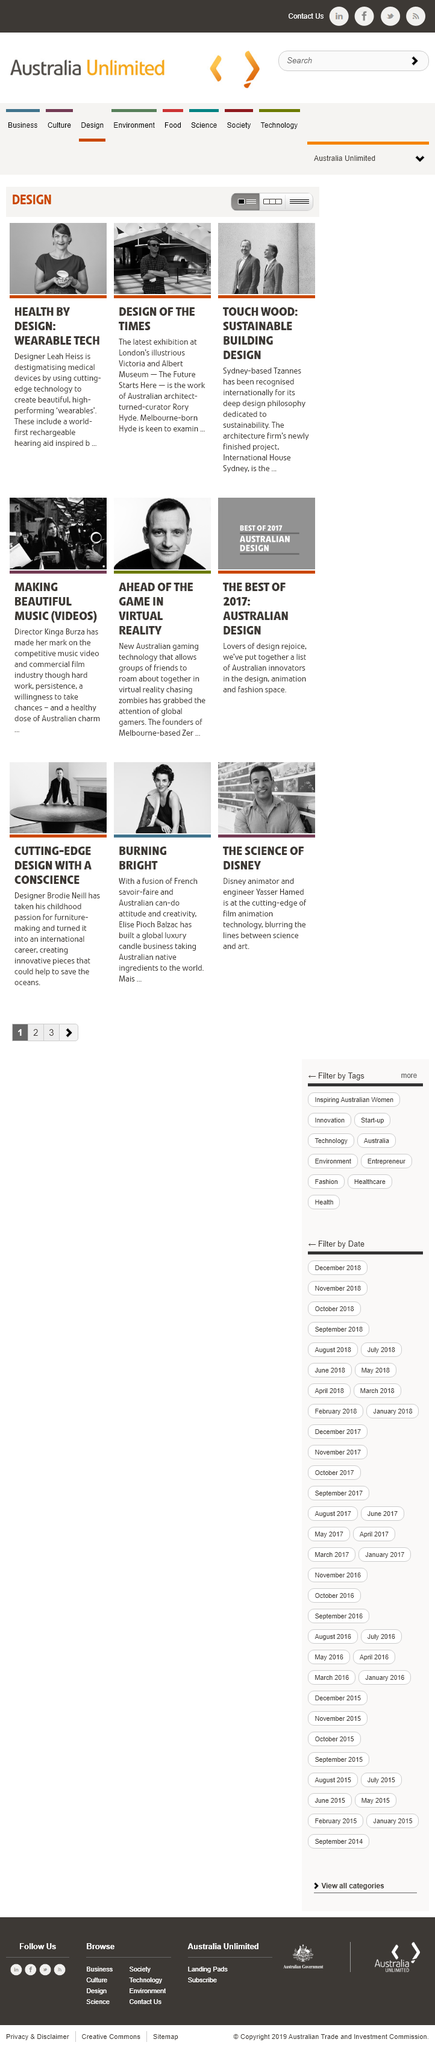Point out several critical features in this image. Tzannes is based in Sydney, and it is known for its innovative architectural designs. Rory Hyde, who was born in Melbourne, is known for his contributions to the field of architecture and design. Leah Heiss, a designer, is creating Wearable Tech. 